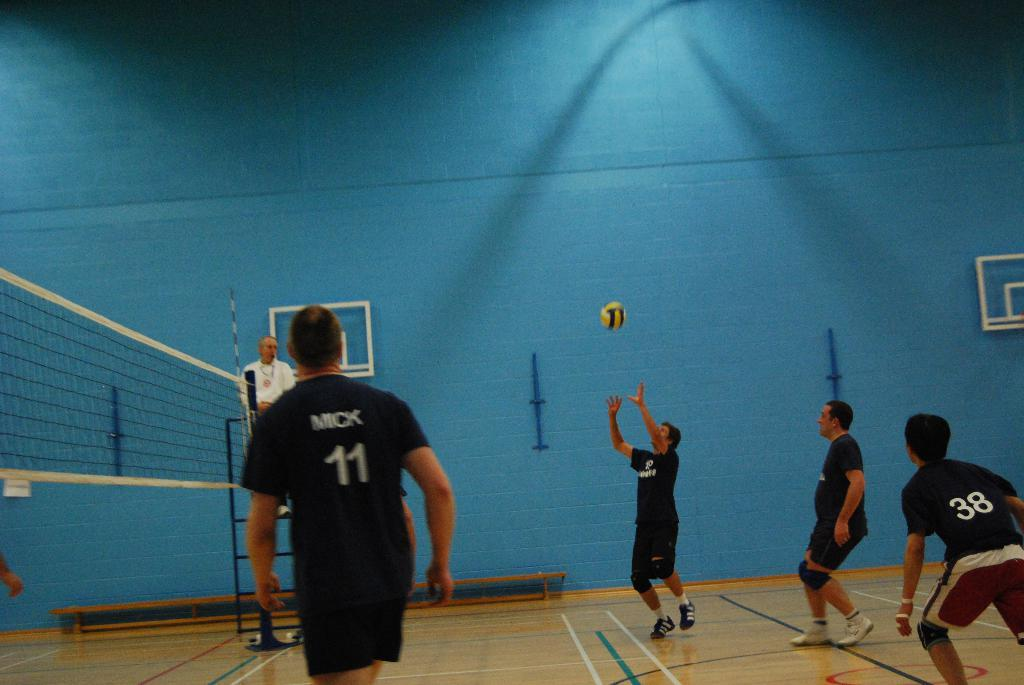<image>
Render a clear and concise summary of the photo. the number 11 is on the back of the shirt 